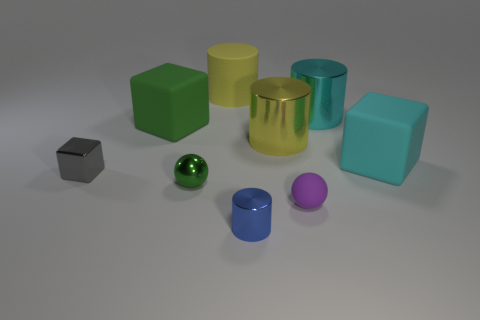Subtract all blue cylinders. How many cylinders are left? 3 Add 1 metallic cubes. How many objects exist? 10 Subtract all yellow cylinders. How many cylinders are left? 2 Subtract all cylinders. How many objects are left? 5 Subtract 1 blocks. How many blocks are left? 2 Subtract all cyan balls. Subtract all gray cubes. How many balls are left? 2 Subtract all blue blocks. How many green balls are left? 1 Subtract all cubes. Subtract all blue cylinders. How many objects are left? 5 Add 7 large yellow metallic objects. How many large yellow metallic objects are left? 8 Add 2 large yellow matte cylinders. How many large yellow matte cylinders exist? 3 